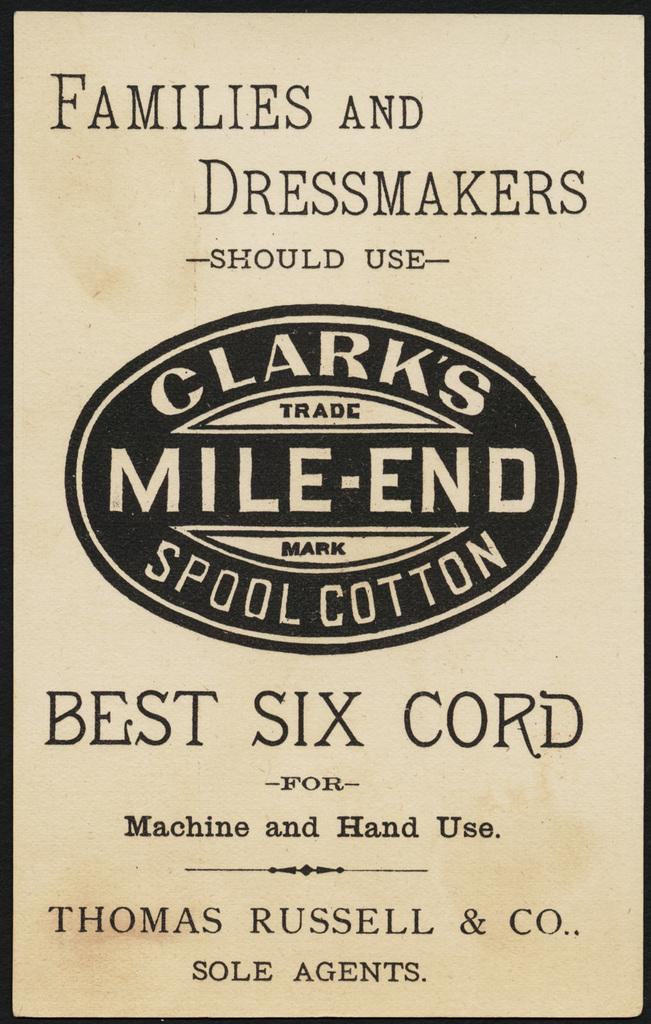<image>
Offer a succinct explanation of the picture presented. A tan box of stating the brand Clark's Mile-End Spool Cotton 